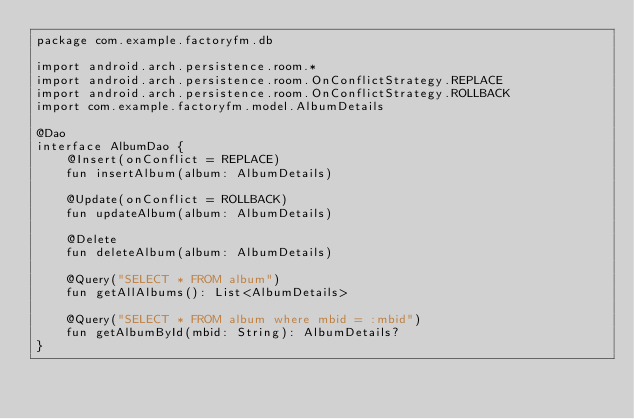<code> <loc_0><loc_0><loc_500><loc_500><_Kotlin_>package com.example.factoryfm.db

import android.arch.persistence.room.*
import android.arch.persistence.room.OnConflictStrategy.REPLACE
import android.arch.persistence.room.OnConflictStrategy.ROLLBACK
import com.example.factoryfm.model.AlbumDetails

@Dao
interface AlbumDao {
    @Insert(onConflict = REPLACE)
    fun insertAlbum(album: AlbumDetails)

    @Update(onConflict = ROLLBACK)
    fun updateAlbum(album: AlbumDetails)

    @Delete
    fun deleteAlbum(album: AlbumDetails)

    @Query("SELECT * FROM album")
    fun getAllAlbums(): List<AlbumDetails>

    @Query("SELECT * FROM album where mbid = :mbid")
    fun getAlbumById(mbid: String): AlbumDetails?
}</code> 